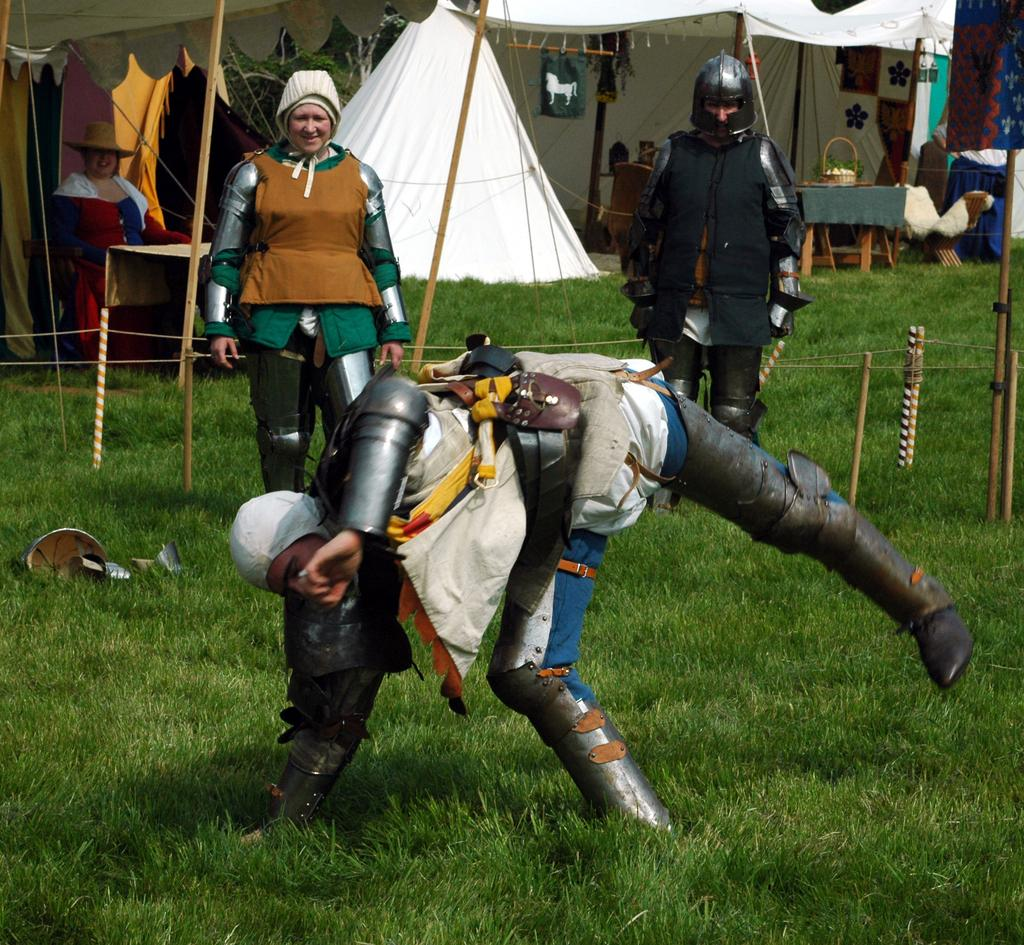How many people are in the image? There are four people on the ground in the image. What type of terrain is visible in the image? There is grass visible in the image. What objects can be seen in the image that are used for support or construction? Wooden sticks and ropes are visible in the image. What type of temporary shelter is present in the image? Tents are present in the image. What type of furniture is visible in the image? Tables are visible in the image. Can you describe any objects present in the image? There are objects in the image, but their specific nature is not mentioned in the provided facts. What type of potato is being used to cover the tents in the image? There is no potato present in the image, nor is there any mention of a potato being used to cover the tents. 